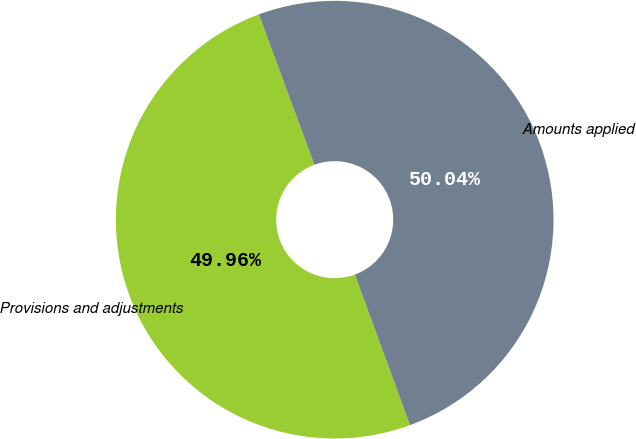<chart> <loc_0><loc_0><loc_500><loc_500><pie_chart><fcel>Provisions and adjustments<fcel>Amounts applied<nl><fcel>49.96%<fcel>50.04%<nl></chart> 